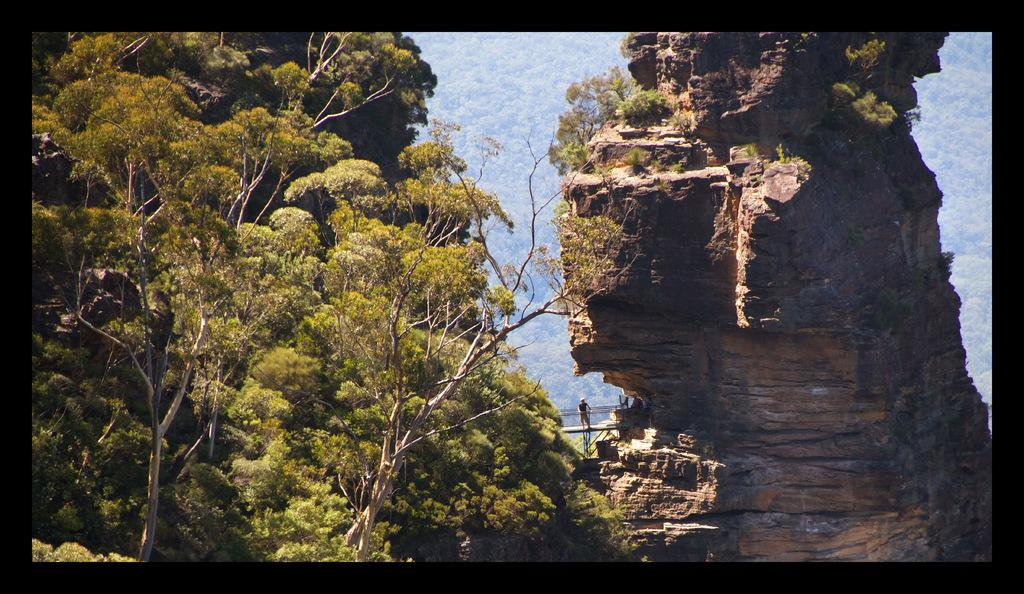What type of vegetation is on the left side of the image? There are trees on the left side of the image. What can be seen in the middle of the image? A person is standing in the middle of the image. What type of landscape feature is on the right side of the image? There is a hill on the right side of the image. What type of card is being used by the person in the image? There is no card present in the image; it only shows trees, a person, and a hill. What kind of animal can be seen interacting with the person in the image? There is no animal present in the image; it only shows trees, a person, and a hill. 